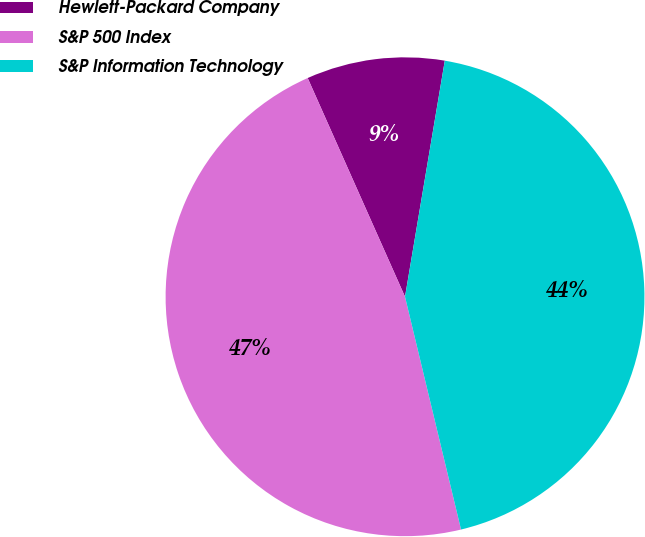Convert chart. <chart><loc_0><loc_0><loc_500><loc_500><pie_chart><fcel>Hewlett-Packard Company<fcel>S&P 500 Index<fcel>S&P Information Technology<nl><fcel>9.32%<fcel>47.09%<fcel>43.58%<nl></chart> 